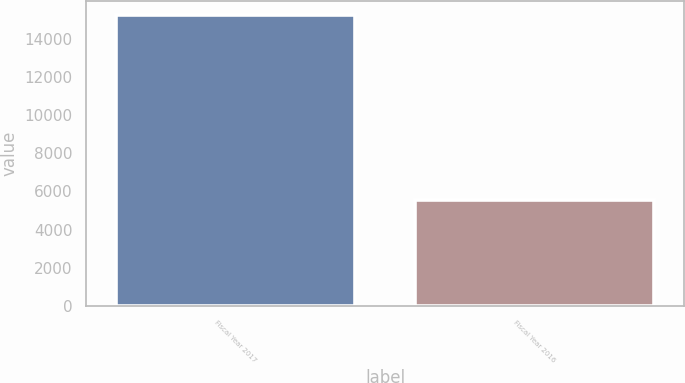Convert chart. <chart><loc_0><loc_0><loc_500><loc_500><bar_chart><fcel>Fiscal Year 2017<fcel>Fiscal Year 2016<nl><fcel>15220<fcel>5535<nl></chart> 